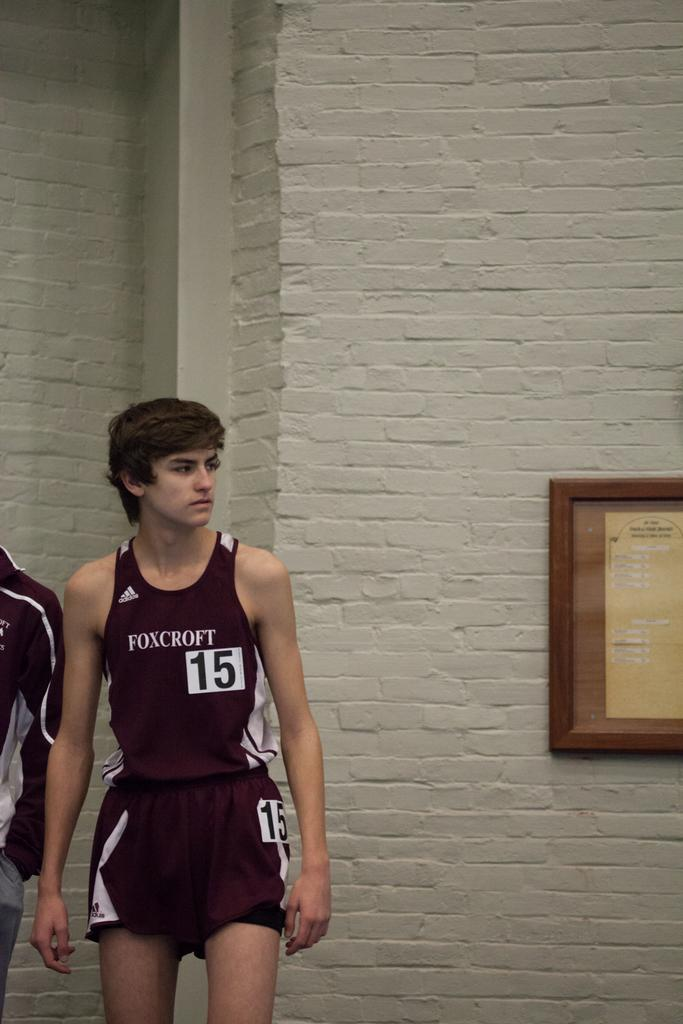<image>
Share a concise interpretation of the image provided. A Foxcroft player wearing the number 15 in a gym. 